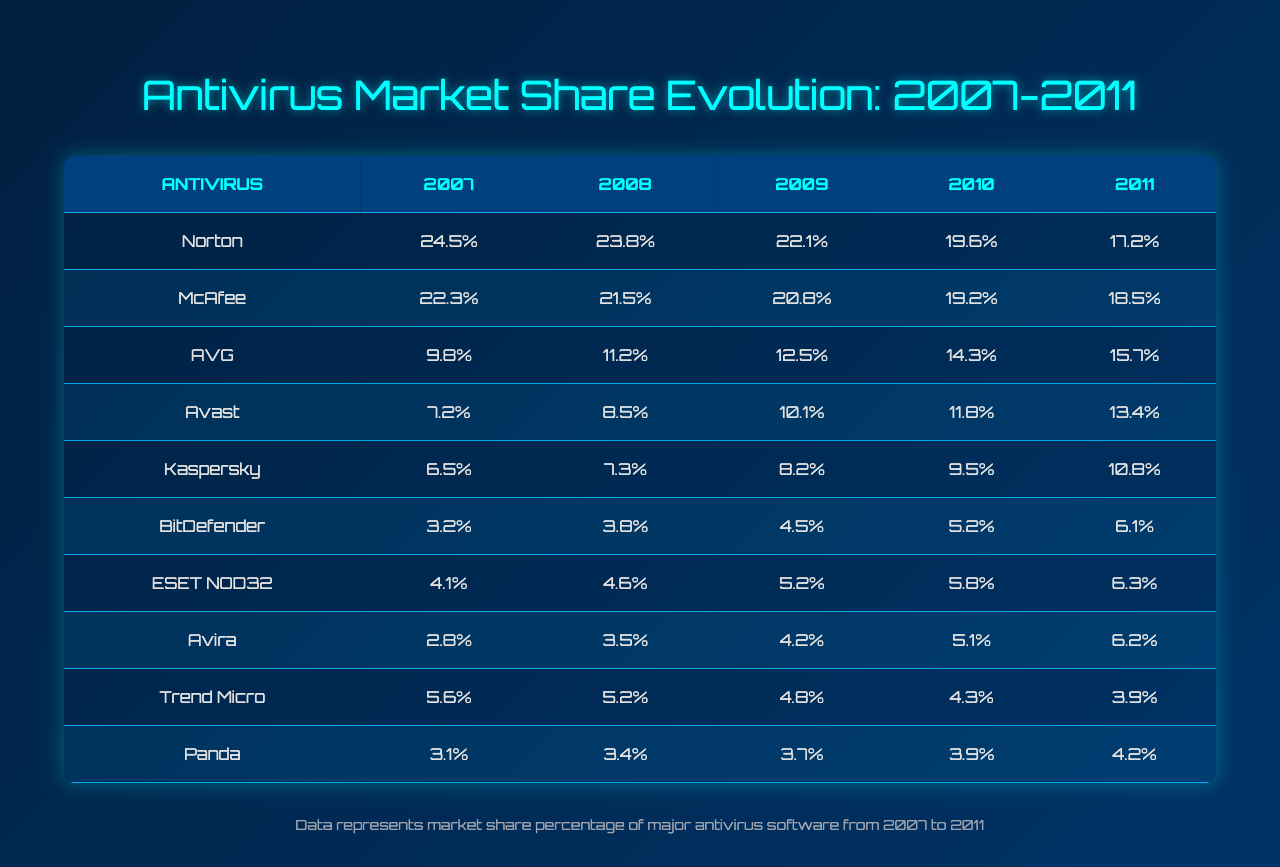What was the market share percentage of Norton in 2009? From the table, in the year 2009, the market share percentage of Norton is directly listed as 22.1%.
Answer: 22.1% Which antivirus software had the highest market share in 2007? By checking the table, Norton has the highest market share in 2007, which is recorded at 24.5%.
Answer: Norton What is the average market share of AVG from 2007 to 2011? To find the average, sum the values from 2007 to 2011 for AVG: 9.8 + 11.2 + 12.5 + 14.3 + 15.7 = 63.5. Then divide by the number of years (5): 63.5 / 5 = 12.7.
Answer: 12.7 Did Kaspersky's market share increase or decrease from 2007 to 2011? Comparing the values, Kaspersky's share in 2007 was 6.5% and in 2011 it increased to 10.8%, showing an increase.
Answer: Increase In which year did Trend Micro see its lowest market share, and what was the percentage? Looking at the table, Trend Micro's market shares were 5.6%, 5.2%, 4.8%, 4.3%, and 3.9% from 2007 to 2011. The lowest percentage is 3.9% in 2011.
Answer: 2011, 3.9% What is the difference in market share percentage of McAfee from 2007 to 2011? McAfee in 2007 had a share of 22.3% and in 2011 it had 18.5%. The difference is 22.3% - 18.5% = 3.8%.
Answer: 3.8% Which antivirus software had the second lowest market share in 2010? In 2010, the shares were: Norton (19.6%), McAfee (19.2%), AVG (14.3%), Avast (11.8%), Kaspersky (9.5%), BitDefender (5.2%), ESET NOD32 (5.8%), Avira (5.1%), Trend Micro (4.3%), Panda (3.9%). The second lowest is ESET NOD32 with 5.8%.
Answer: ESET NOD32 If you combine the market shares of AVG and Avast in 2011, what is the total? In 2011, AVG had a market share of 15.7% and Avast had 13.4%. Adding them together gives 15.7 + 13.4 = 29.1%.
Answer: 29.1% Was there any year where Panda had a higher market share than BitDefender? By reviewing the table, Panda's percentages (3.1%, 3.4%, 3.7%, 3.9%, 4.2%) are always higher than BitDefender's percentages (3.2%, 3.8%, 4.5%, 5.2%, 6.1%) only in the years 2007 and 2008.
Answer: Yes What was the overall trend of Norton from 2007 to 2011? Examining the table reveals that Norton's market share decreased consistently from 24.5% in 2007 to 17.2% in 2011, indicating a downward trend.
Answer: Downward trend 